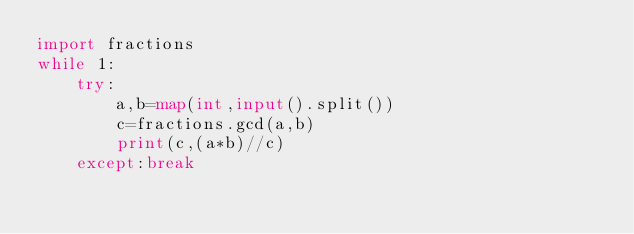Convert code to text. <code><loc_0><loc_0><loc_500><loc_500><_Python_>import fractions
while 1:
    try:
        a,b=map(int,input().split())
        c=fractions.gcd(a,b)
        print(c,(a*b)//c)
    except:break</code> 